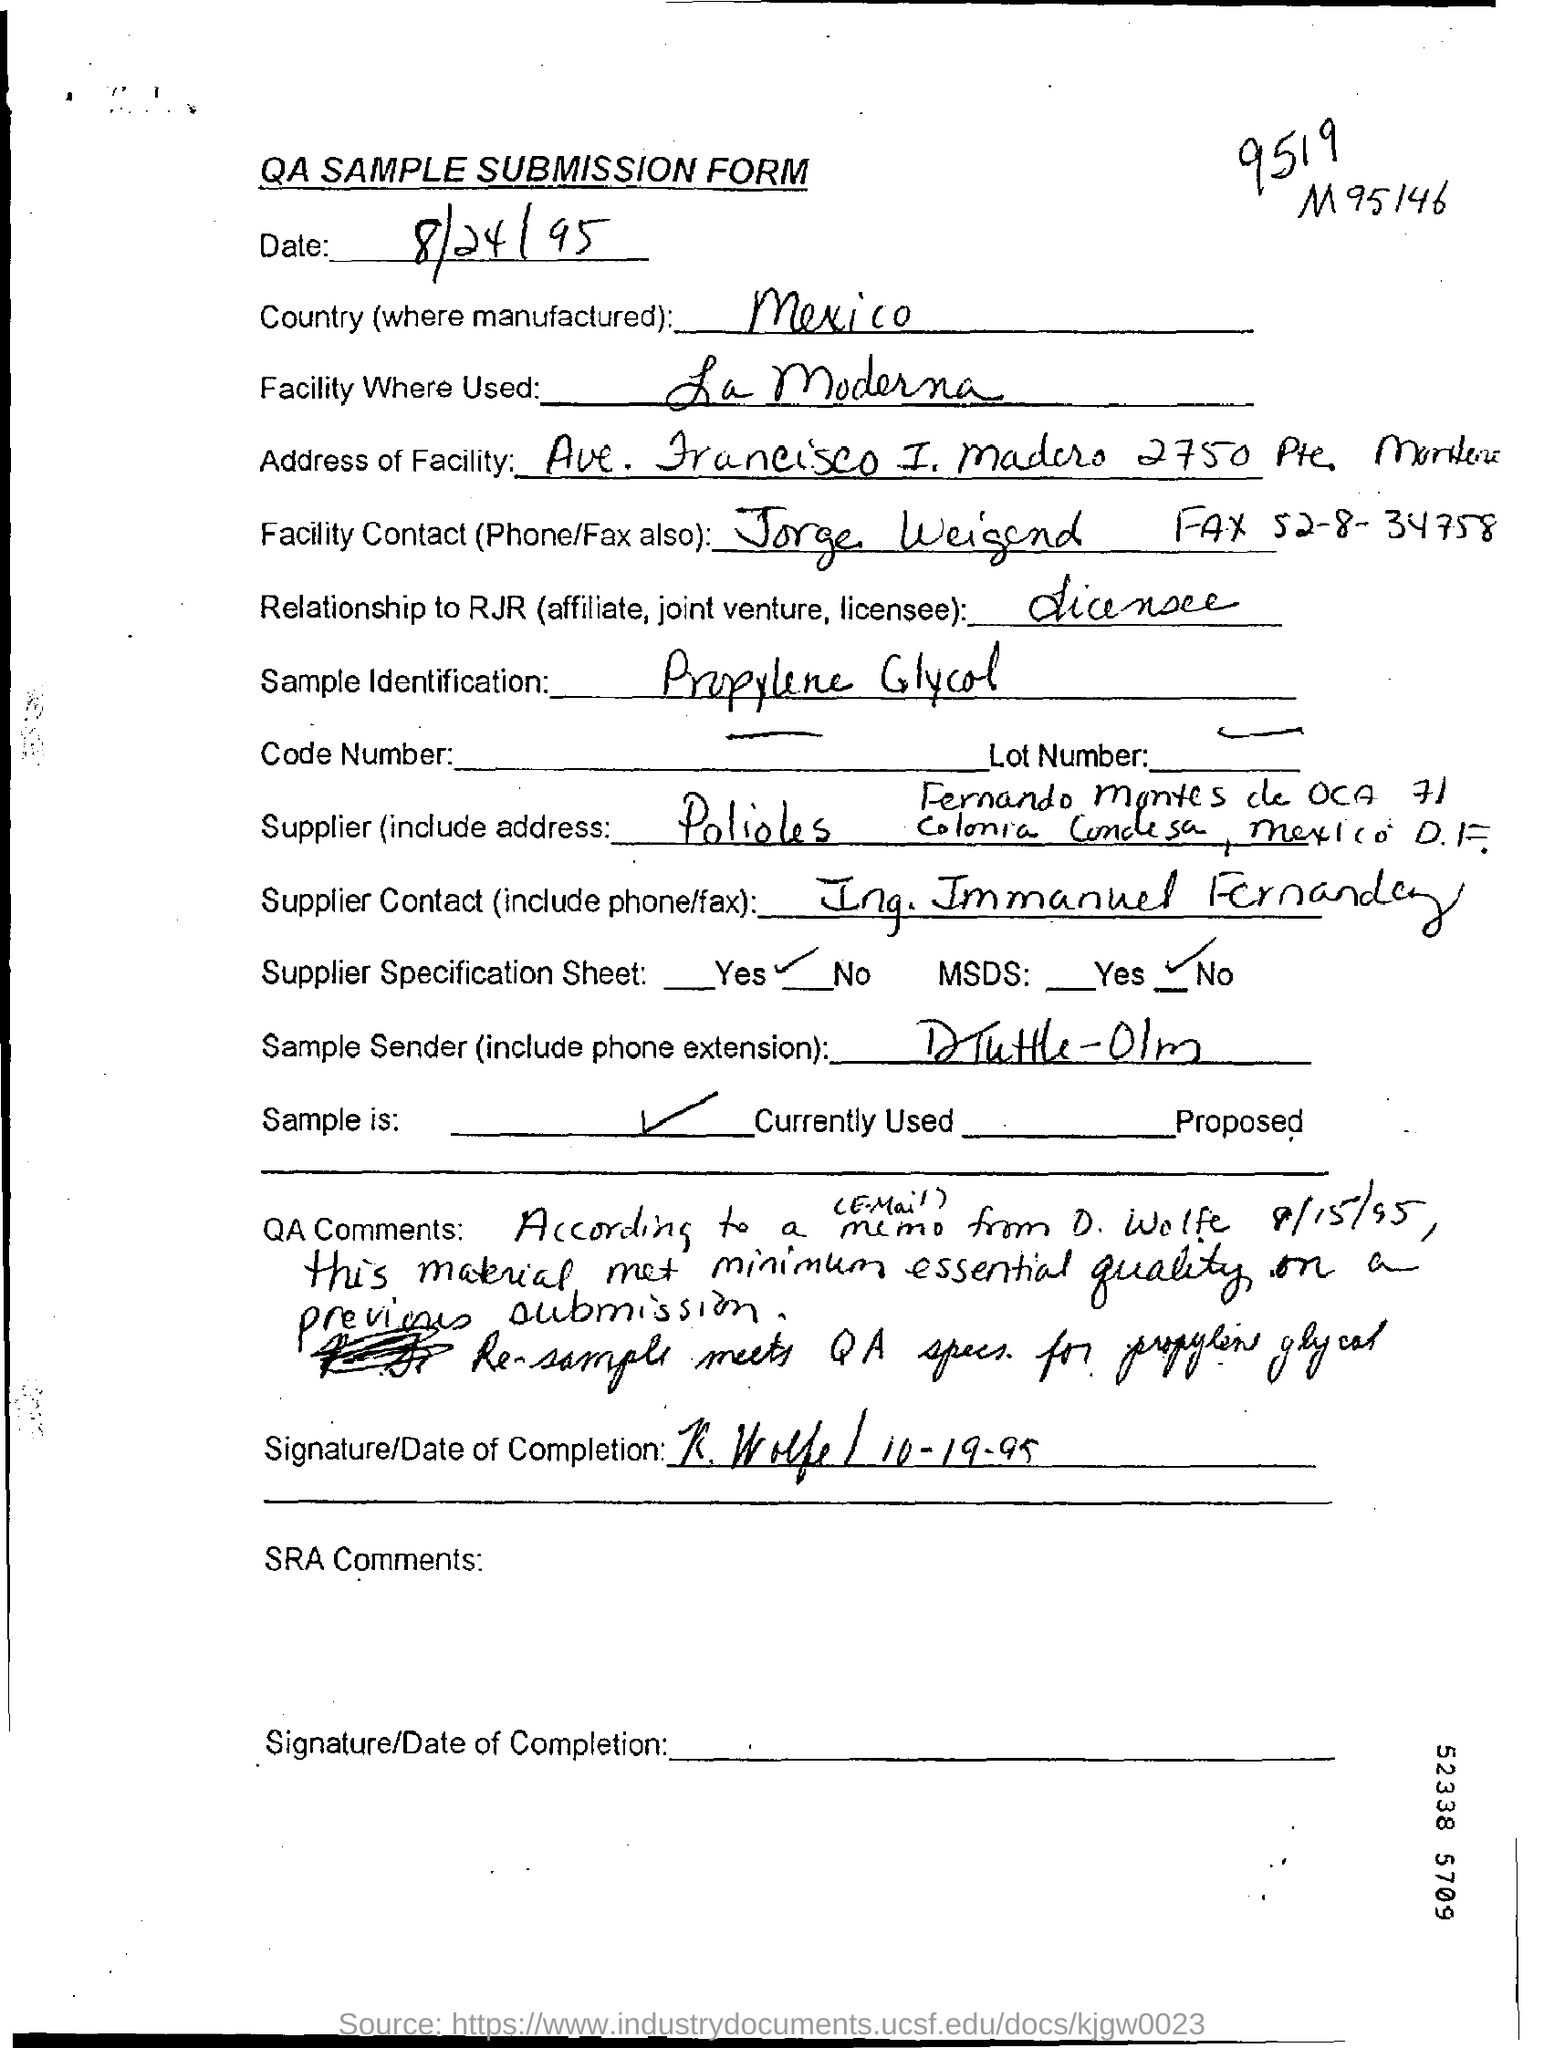Identify some key points in this picture. The sample is identified as propylene glycol. This document dates back to the year 1995. The headline of the document is 'QA SAMPLE SUBMISSION FORM.' The country mentioned is Mexico. 